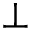Convert formula to latex. <formula><loc_0><loc_0><loc_500><loc_500>\perp</formula> 